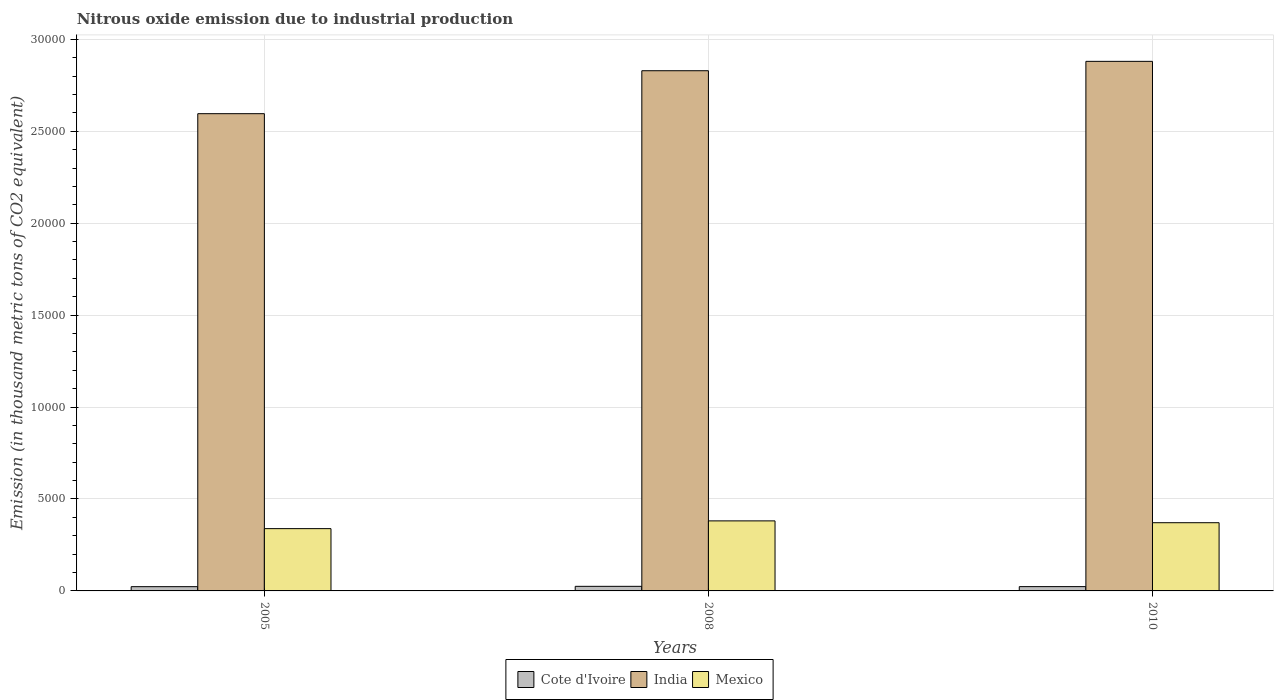Are the number of bars per tick equal to the number of legend labels?
Your response must be concise. Yes. Are the number of bars on each tick of the X-axis equal?
Your answer should be compact. Yes. How many bars are there on the 2nd tick from the left?
Provide a short and direct response. 3. How many bars are there on the 1st tick from the right?
Your answer should be compact. 3. What is the amount of nitrous oxide emitted in Mexico in 2008?
Keep it short and to the point. 3808.7. Across all years, what is the maximum amount of nitrous oxide emitted in Mexico?
Make the answer very short. 3808.7. Across all years, what is the minimum amount of nitrous oxide emitted in Mexico?
Your answer should be compact. 3387.8. In which year was the amount of nitrous oxide emitted in Mexico minimum?
Offer a very short reply. 2005. What is the total amount of nitrous oxide emitted in Cote d'Ivoire in the graph?
Your answer should be very brief. 714.8. What is the difference between the amount of nitrous oxide emitted in Cote d'Ivoire in 2005 and that in 2008?
Your response must be concise. -17.4. What is the difference between the amount of nitrous oxide emitted in Cote d'Ivoire in 2010 and the amount of nitrous oxide emitted in Mexico in 2005?
Your answer should be compact. -3154. What is the average amount of nitrous oxide emitted in Mexico per year?
Provide a succinct answer. 3635.23. In the year 2005, what is the difference between the amount of nitrous oxide emitted in Mexico and amount of nitrous oxide emitted in Cote d'Ivoire?
Provide a short and direct response. 3156. In how many years, is the amount of nitrous oxide emitted in Cote d'Ivoire greater than 23000 thousand metric tons?
Provide a short and direct response. 0. What is the ratio of the amount of nitrous oxide emitted in Mexico in 2005 to that in 2008?
Keep it short and to the point. 0.89. Is the difference between the amount of nitrous oxide emitted in Mexico in 2005 and 2010 greater than the difference between the amount of nitrous oxide emitted in Cote d'Ivoire in 2005 and 2010?
Give a very brief answer. No. What is the difference between the highest and the second highest amount of nitrous oxide emitted in Cote d'Ivoire?
Offer a terse response. 15.4. What is the difference between the highest and the lowest amount of nitrous oxide emitted in India?
Offer a very short reply. 2845.9. Is the sum of the amount of nitrous oxide emitted in India in 2008 and 2010 greater than the maximum amount of nitrous oxide emitted in Mexico across all years?
Ensure brevity in your answer.  Yes. What does the 1st bar from the left in 2008 represents?
Provide a succinct answer. Cote d'Ivoire. What does the 1st bar from the right in 2008 represents?
Your answer should be compact. Mexico. Is it the case that in every year, the sum of the amount of nitrous oxide emitted in Cote d'Ivoire and amount of nitrous oxide emitted in Mexico is greater than the amount of nitrous oxide emitted in India?
Your answer should be very brief. No. Are all the bars in the graph horizontal?
Provide a short and direct response. No. How many years are there in the graph?
Your answer should be compact. 3. Does the graph contain any zero values?
Your answer should be compact. No. Does the graph contain grids?
Your answer should be very brief. Yes. Where does the legend appear in the graph?
Provide a short and direct response. Bottom center. How many legend labels are there?
Offer a very short reply. 3. How are the legend labels stacked?
Your answer should be compact. Horizontal. What is the title of the graph?
Your response must be concise. Nitrous oxide emission due to industrial production. Does "Kenya" appear as one of the legend labels in the graph?
Make the answer very short. No. What is the label or title of the X-axis?
Make the answer very short. Years. What is the label or title of the Y-axis?
Ensure brevity in your answer.  Emission (in thousand metric tons of CO2 equivalent). What is the Emission (in thousand metric tons of CO2 equivalent) of Cote d'Ivoire in 2005?
Make the answer very short. 231.8. What is the Emission (in thousand metric tons of CO2 equivalent) in India in 2005?
Keep it short and to the point. 2.60e+04. What is the Emission (in thousand metric tons of CO2 equivalent) in Mexico in 2005?
Your answer should be compact. 3387.8. What is the Emission (in thousand metric tons of CO2 equivalent) of Cote d'Ivoire in 2008?
Your response must be concise. 249.2. What is the Emission (in thousand metric tons of CO2 equivalent) in India in 2008?
Offer a terse response. 2.83e+04. What is the Emission (in thousand metric tons of CO2 equivalent) of Mexico in 2008?
Ensure brevity in your answer.  3808.7. What is the Emission (in thousand metric tons of CO2 equivalent) in Cote d'Ivoire in 2010?
Keep it short and to the point. 233.8. What is the Emission (in thousand metric tons of CO2 equivalent) of India in 2010?
Give a very brief answer. 2.88e+04. What is the Emission (in thousand metric tons of CO2 equivalent) of Mexico in 2010?
Provide a succinct answer. 3709.2. Across all years, what is the maximum Emission (in thousand metric tons of CO2 equivalent) in Cote d'Ivoire?
Offer a very short reply. 249.2. Across all years, what is the maximum Emission (in thousand metric tons of CO2 equivalent) of India?
Make the answer very short. 2.88e+04. Across all years, what is the maximum Emission (in thousand metric tons of CO2 equivalent) in Mexico?
Offer a very short reply. 3808.7. Across all years, what is the minimum Emission (in thousand metric tons of CO2 equivalent) of Cote d'Ivoire?
Keep it short and to the point. 231.8. Across all years, what is the minimum Emission (in thousand metric tons of CO2 equivalent) of India?
Keep it short and to the point. 2.60e+04. Across all years, what is the minimum Emission (in thousand metric tons of CO2 equivalent) in Mexico?
Make the answer very short. 3387.8. What is the total Emission (in thousand metric tons of CO2 equivalent) in Cote d'Ivoire in the graph?
Your answer should be very brief. 714.8. What is the total Emission (in thousand metric tons of CO2 equivalent) of India in the graph?
Offer a very short reply. 8.30e+04. What is the total Emission (in thousand metric tons of CO2 equivalent) in Mexico in the graph?
Your response must be concise. 1.09e+04. What is the difference between the Emission (in thousand metric tons of CO2 equivalent) of Cote d'Ivoire in 2005 and that in 2008?
Ensure brevity in your answer.  -17.4. What is the difference between the Emission (in thousand metric tons of CO2 equivalent) in India in 2005 and that in 2008?
Your response must be concise. -2335.9. What is the difference between the Emission (in thousand metric tons of CO2 equivalent) of Mexico in 2005 and that in 2008?
Ensure brevity in your answer.  -420.9. What is the difference between the Emission (in thousand metric tons of CO2 equivalent) in Cote d'Ivoire in 2005 and that in 2010?
Make the answer very short. -2. What is the difference between the Emission (in thousand metric tons of CO2 equivalent) of India in 2005 and that in 2010?
Your answer should be compact. -2845.9. What is the difference between the Emission (in thousand metric tons of CO2 equivalent) of Mexico in 2005 and that in 2010?
Offer a very short reply. -321.4. What is the difference between the Emission (in thousand metric tons of CO2 equivalent) in India in 2008 and that in 2010?
Provide a succinct answer. -510. What is the difference between the Emission (in thousand metric tons of CO2 equivalent) in Mexico in 2008 and that in 2010?
Make the answer very short. 99.5. What is the difference between the Emission (in thousand metric tons of CO2 equivalent) in Cote d'Ivoire in 2005 and the Emission (in thousand metric tons of CO2 equivalent) in India in 2008?
Provide a short and direct response. -2.81e+04. What is the difference between the Emission (in thousand metric tons of CO2 equivalent) in Cote d'Ivoire in 2005 and the Emission (in thousand metric tons of CO2 equivalent) in Mexico in 2008?
Keep it short and to the point. -3576.9. What is the difference between the Emission (in thousand metric tons of CO2 equivalent) in India in 2005 and the Emission (in thousand metric tons of CO2 equivalent) in Mexico in 2008?
Keep it short and to the point. 2.21e+04. What is the difference between the Emission (in thousand metric tons of CO2 equivalent) of Cote d'Ivoire in 2005 and the Emission (in thousand metric tons of CO2 equivalent) of India in 2010?
Provide a short and direct response. -2.86e+04. What is the difference between the Emission (in thousand metric tons of CO2 equivalent) in Cote d'Ivoire in 2005 and the Emission (in thousand metric tons of CO2 equivalent) in Mexico in 2010?
Provide a short and direct response. -3477.4. What is the difference between the Emission (in thousand metric tons of CO2 equivalent) of India in 2005 and the Emission (in thousand metric tons of CO2 equivalent) of Mexico in 2010?
Offer a terse response. 2.22e+04. What is the difference between the Emission (in thousand metric tons of CO2 equivalent) in Cote d'Ivoire in 2008 and the Emission (in thousand metric tons of CO2 equivalent) in India in 2010?
Your response must be concise. -2.86e+04. What is the difference between the Emission (in thousand metric tons of CO2 equivalent) in Cote d'Ivoire in 2008 and the Emission (in thousand metric tons of CO2 equivalent) in Mexico in 2010?
Your answer should be compact. -3460. What is the difference between the Emission (in thousand metric tons of CO2 equivalent) in India in 2008 and the Emission (in thousand metric tons of CO2 equivalent) in Mexico in 2010?
Ensure brevity in your answer.  2.46e+04. What is the average Emission (in thousand metric tons of CO2 equivalent) of Cote d'Ivoire per year?
Your response must be concise. 238.27. What is the average Emission (in thousand metric tons of CO2 equivalent) of India per year?
Ensure brevity in your answer.  2.77e+04. What is the average Emission (in thousand metric tons of CO2 equivalent) of Mexico per year?
Ensure brevity in your answer.  3635.23. In the year 2005, what is the difference between the Emission (in thousand metric tons of CO2 equivalent) in Cote d'Ivoire and Emission (in thousand metric tons of CO2 equivalent) in India?
Make the answer very short. -2.57e+04. In the year 2005, what is the difference between the Emission (in thousand metric tons of CO2 equivalent) of Cote d'Ivoire and Emission (in thousand metric tons of CO2 equivalent) of Mexico?
Keep it short and to the point. -3156. In the year 2005, what is the difference between the Emission (in thousand metric tons of CO2 equivalent) of India and Emission (in thousand metric tons of CO2 equivalent) of Mexico?
Offer a terse response. 2.26e+04. In the year 2008, what is the difference between the Emission (in thousand metric tons of CO2 equivalent) in Cote d'Ivoire and Emission (in thousand metric tons of CO2 equivalent) in India?
Your answer should be compact. -2.80e+04. In the year 2008, what is the difference between the Emission (in thousand metric tons of CO2 equivalent) in Cote d'Ivoire and Emission (in thousand metric tons of CO2 equivalent) in Mexico?
Offer a terse response. -3559.5. In the year 2008, what is the difference between the Emission (in thousand metric tons of CO2 equivalent) of India and Emission (in thousand metric tons of CO2 equivalent) of Mexico?
Your answer should be very brief. 2.45e+04. In the year 2010, what is the difference between the Emission (in thousand metric tons of CO2 equivalent) of Cote d'Ivoire and Emission (in thousand metric tons of CO2 equivalent) of India?
Your answer should be compact. -2.86e+04. In the year 2010, what is the difference between the Emission (in thousand metric tons of CO2 equivalent) of Cote d'Ivoire and Emission (in thousand metric tons of CO2 equivalent) of Mexico?
Make the answer very short. -3475.4. In the year 2010, what is the difference between the Emission (in thousand metric tons of CO2 equivalent) in India and Emission (in thousand metric tons of CO2 equivalent) in Mexico?
Ensure brevity in your answer.  2.51e+04. What is the ratio of the Emission (in thousand metric tons of CO2 equivalent) of Cote d'Ivoire in 2005 to that in 2008?
Make the answer very short. 0.93. What is the ratio of the Emission (in thousand metric tons of CO2 equivalent) of India in 2005 to that in 2008?
Your answer should be very brief. 0.92. What is the ratio of the Emission (in thousand metric tons of CO2 equivalent) of Mexico in 2005 to that in 2008?
Your answer should be compact. 0.89. What is the ratio of the Emission (in thousand metric tons of CO2 equivalent) in India in 2005 to that in 2010?
Offer a very short reply. 0.9. What is the ratio of the Emission (in thousand metric tons of CO2 equivalent) of Mexico in 2005 to that in 2010?
Provide a succinct answer. 0.91. What is the ratio of the Emission (in thousand metric tons of CO2 equivalent) of Cote d'Ivoire in 2008 to that in 2010?
Provide a succinct answer. 1.07. What is the ratio of the Emission (in thousand metric tons of CO2 equivalent) in India in 2008 to that in 2010?
Provide a short and direct response. 0.98. What is the ratio of the Emission (in thousand metric tons of CO2 equivalent) of Mexico in 2008 to that in 2010?
Ensure brevity in your answer.  1.03. What is the difference between the highest and the second highest Emission (in thousand metric tons of CO2 equivalent) of India?
Provide a succinct answer. 510. What is the difference between the highest and the second highest Emission (in thousand metric tons of CO2 equivalent) of Mexico?
Give a very brief answer. 99.5. What is the difference between the highest and the lowest Emission (in thousand metric tons of CO2 equivalent) of India?
Your answer should be very brief. 2845.9. What is the difference between the highest and the lowest Emission (in thousand metric tons of CO2 equivalent) of Mexico?
Ensure brevity in your answer.  420.9. 